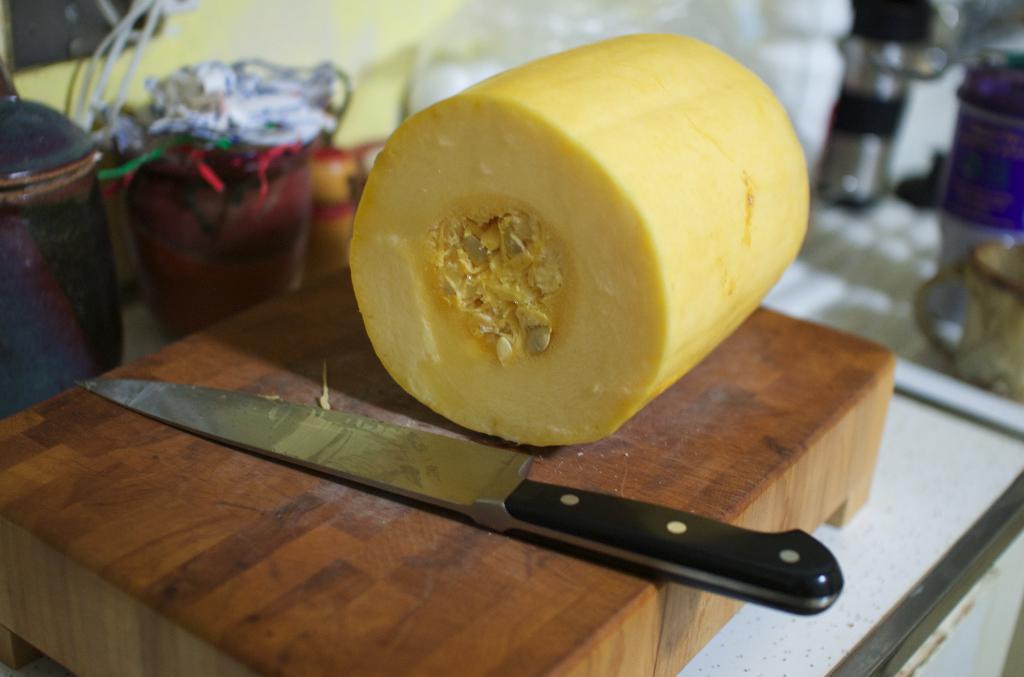In one or two sentences, can you explain what this image depicts? In this image I can see a brown colored surface and on it I can see a knife which is black in color and a food item which is yellow in color. In the background I can see a gas cylinder, the floor and few other objects. 